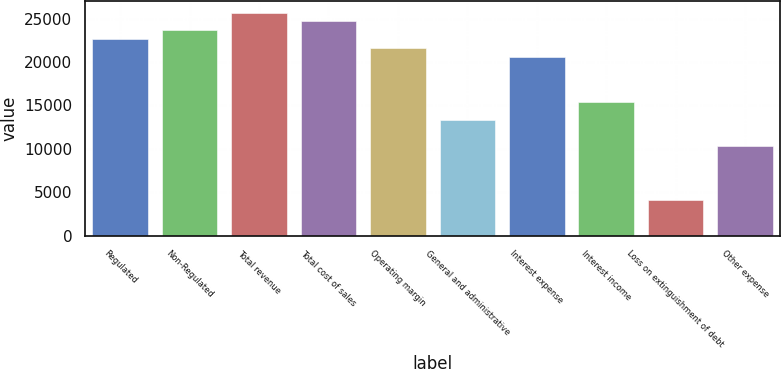Convert chart to OTSL. <chart><loc_0><loc_0><loc_500><loc_500><bar_chart><fcel>Regulated<fcel>Non-Regulated<fcel>Total revenue<fcel>Total cost of sales<fcel>Operating margin<fcel>General and administrative<fcel>Interest expense<fcel>Interest income<fcel>Loss on extinguishment of debt<fcel>Other expense<nl><fcel>22618.2<fcel>23646.3<fcel>25702.5<fcel>24674.4<fcel>21590.1<fcel>13365.3<fcel>20562<fcel>15421.5<fcel>4112.44<fcel>10281<nl></chart> 